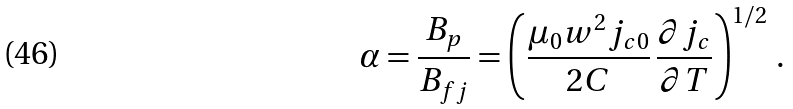<formula> <loc_0><loc_0><loc_500><loc_500>\alpha = \frac { B _ { p } } { B _ { f j } } = \left ( \frac { \mu _ { 0 } w ^ { 2 } j _ { c 0 } } { 2 C } \, \frac { \partial j _ { c } } { \partial T } \right ) ^ { 1 / 2 } \, .</formula> 